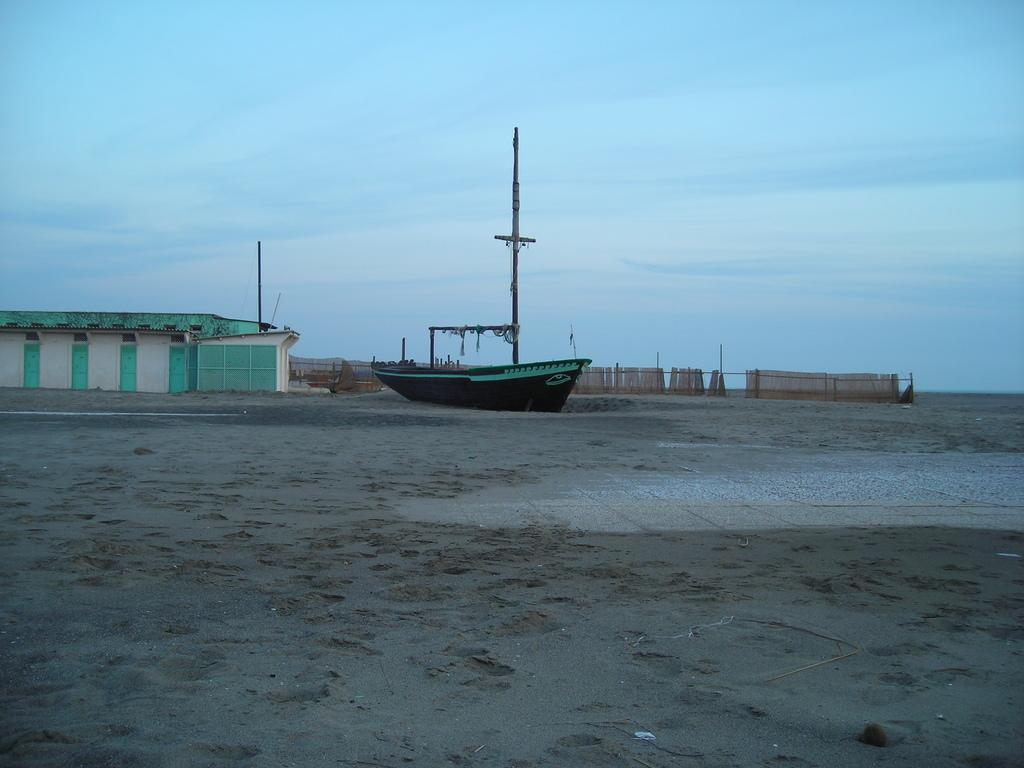What is located in the middle of the image? There is a boat in the middle of the image. What structure is on the left side of the image? There is a shed on the left side of the image. What is visible at the top of the image? The sky is visible at the top of the image. How many rabbits can be seen with a tail in the image? There are no rabbits present in the image. What type of connection can be seen between the boat and the shed in the image? There is no visible connection between the boat and the shed in the image. 